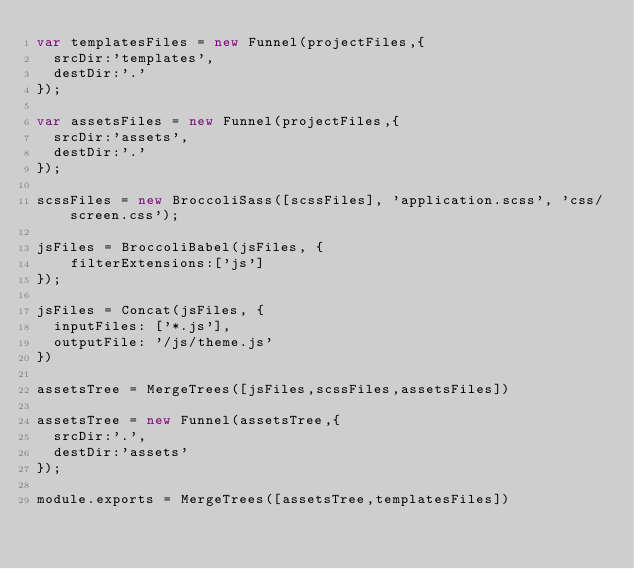<code> <loc_0><loc_0><loc_500><loc_500><_JavaScript_>var templatesFiles = new Funnel(projectFiles,{
  srcDir:'templates',
  destDir:'.'
});

var assetsFiles = new Funnel(projectFiles,{
  srcDir:'assets',
  destDir:'.'
});

scssFiles = new BroccoliSass([scssFiles], 'application.scss', 'css/screen.css');

jsFiles = BroccoliBabel(jsFiles, {
    filterExtensions:['js']
});

jsFiles = Concat(jsFiles, {
  inputFiles: ['*.js'],
  outputFile: '/js/theme.js'
})

assetsTree = MergeTrees([jsFiles,scssFiles,assetsFiles])

assetsTree = new Funnel(assetsTree,{
  srcDir:'.',
  destDir:'assets'
});

module.exports = MergeTrees([assetsTree,templatesFiles])
</code> 